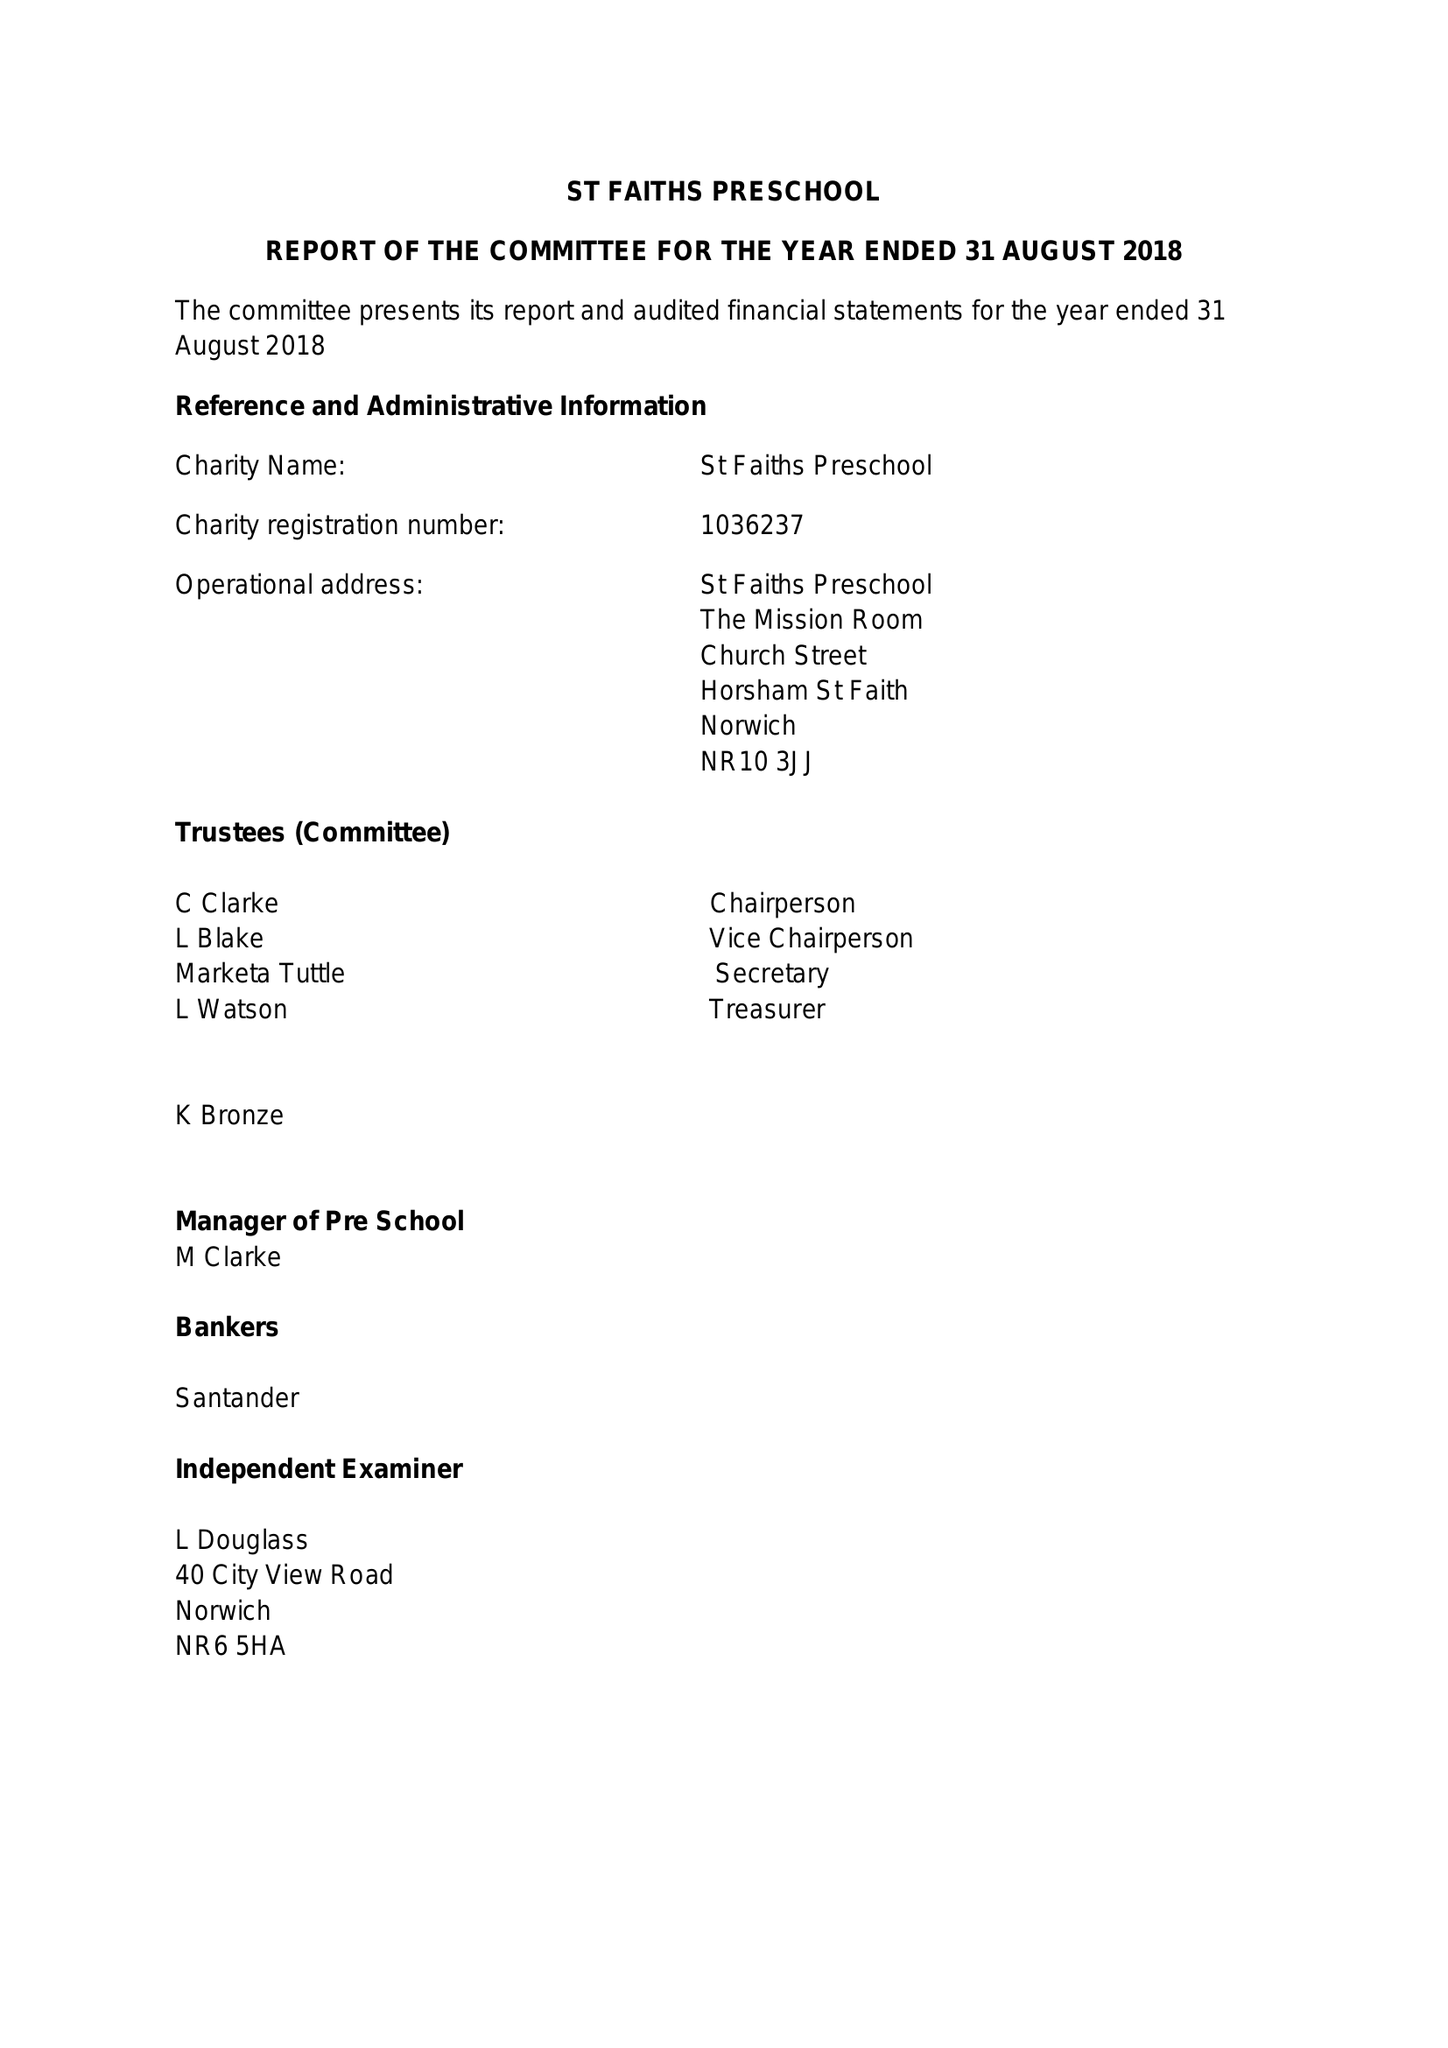What is the value for the address__street_line?
Answer the question using a single word or phrase. CHURCH STREET 